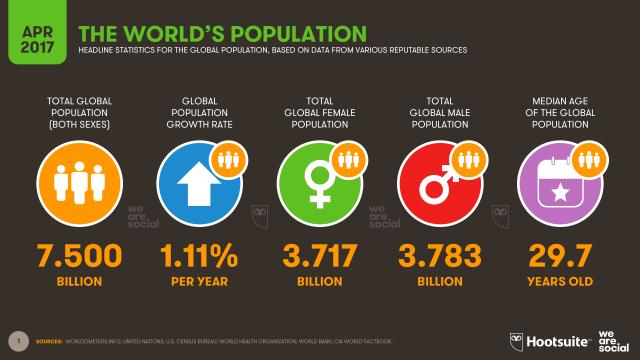Identify some key points in this picture. The total global female population is approximately 3.717 billion. The global population growth rate is 1.11% per year. The total population is approximately 7,500. The total global male population is approximately 3.783 billion. The median age of the global population is 29.7 years. 